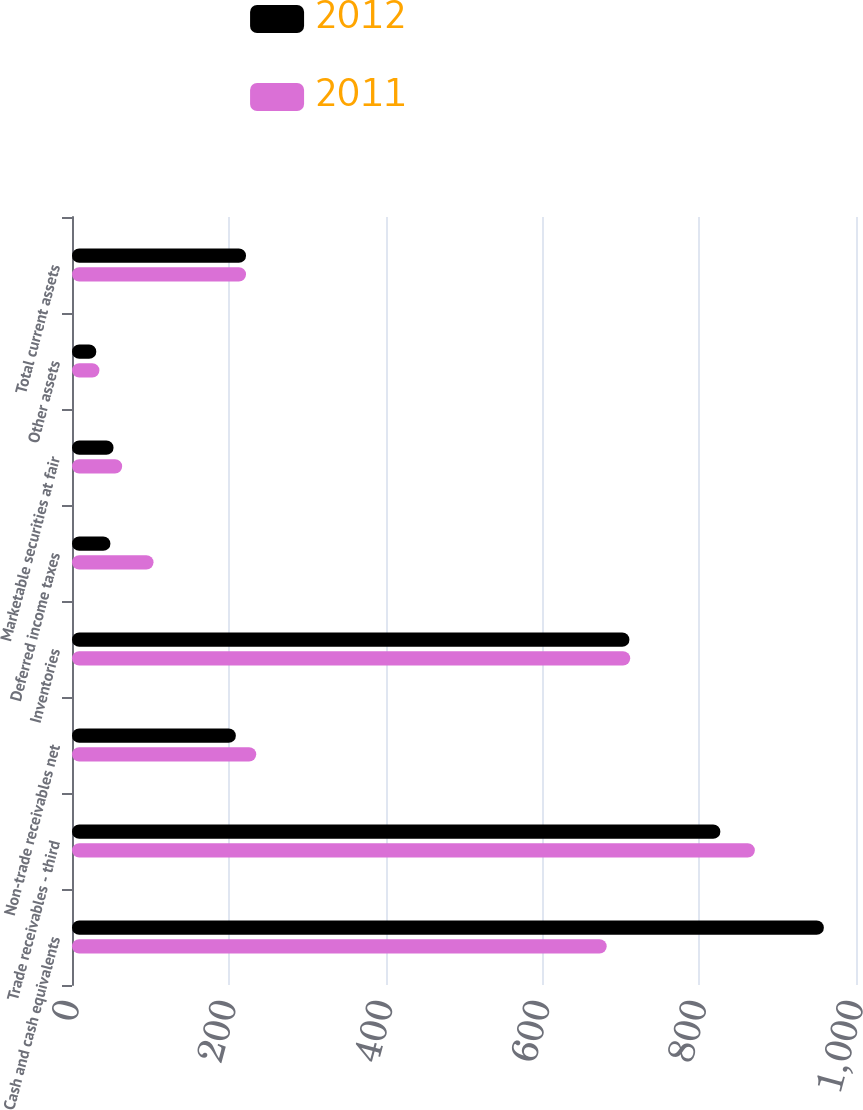<chart> <loc_0><loc_0><loc_500><loc_500><stacked_bar_chart><ecel><fcel>Cash and cash equivalents<fcel>Trade receivables - third<fcel>Non-trade receivables net<fcel>Inventories<fcel>Deferred income taxes<fcel>Marketable securities at fair<fcel>Other assets<fcel>Total current assets<nl><fcel>2012<fcel>959<fcel>827<fcel>209<fcel>711<fcel>49<fcel>53<fcel>31<fcel>222<nl><fcel>2011<fcel>682<fcel>871<fcel>235<fcel>712<fcel>104<fcel>64<fcel>35<fcel>222<nl></chart> 